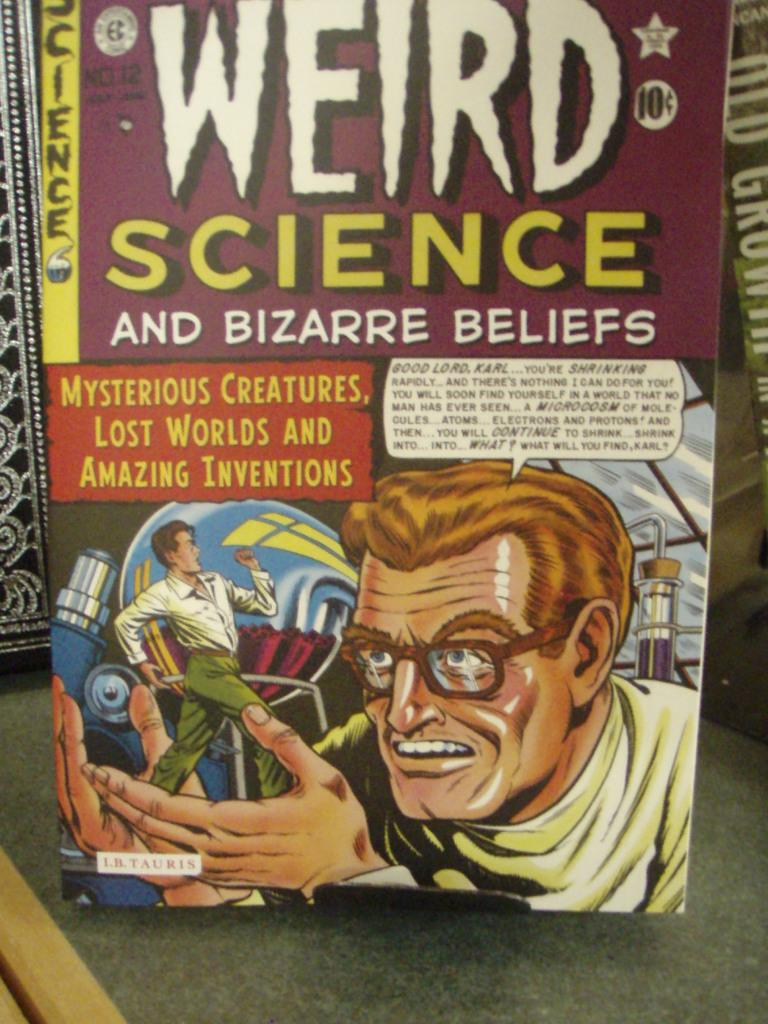<image>
Summarize the visual content of the image. A mad scientist adorns the cover of a Weird Science comic book. 